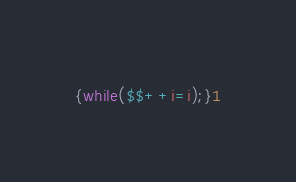<code> <loc_0><loc_0><loc_500><loc_500><_Awk_>{while($$++i=i);}1</code> 